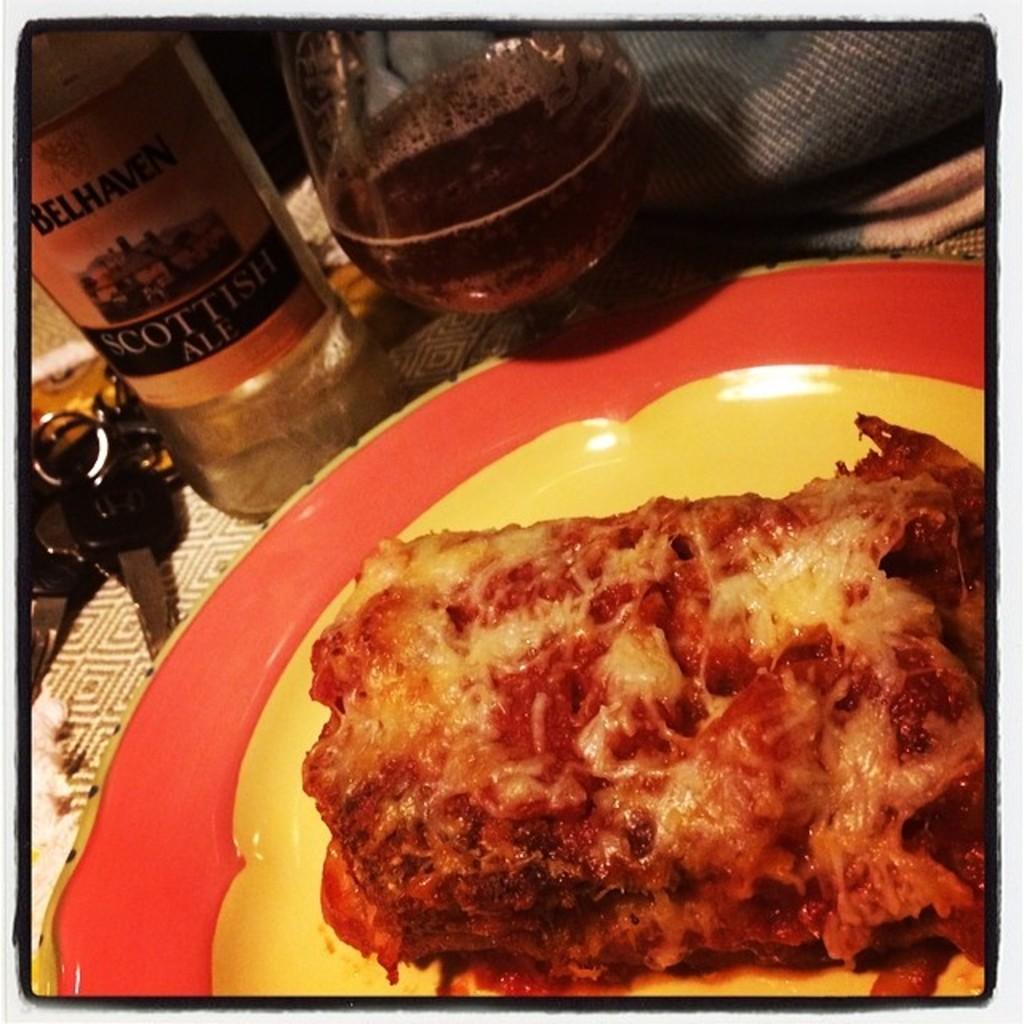What is the brand of ale?
Provide a succinct answer. Belhaven. 